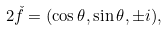<formula> <loc_0><loc_0><loc_500><loc_500>2 \check { f } = ( \cos \theta , \sin \theta , \pm i ) ,</formula> 